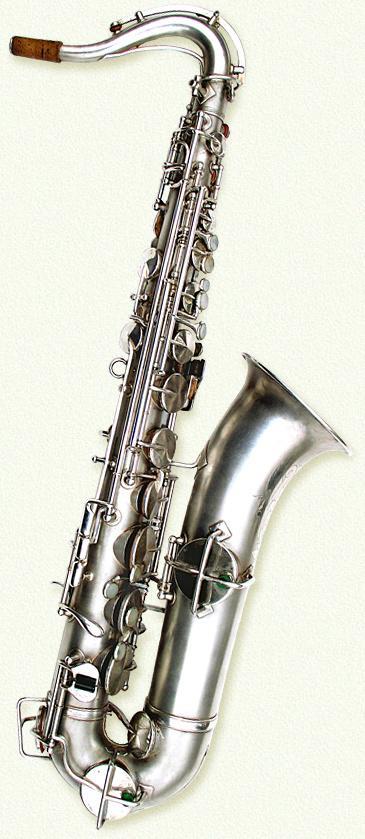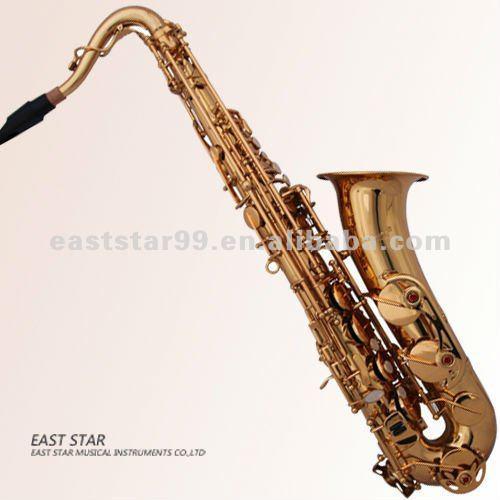The first image is the image on the left, the second image is the image on the right. Considering the images on both sides, is "The left-hand instrument is vertical with a silver body." valid? Answer yes or no. Yes. 